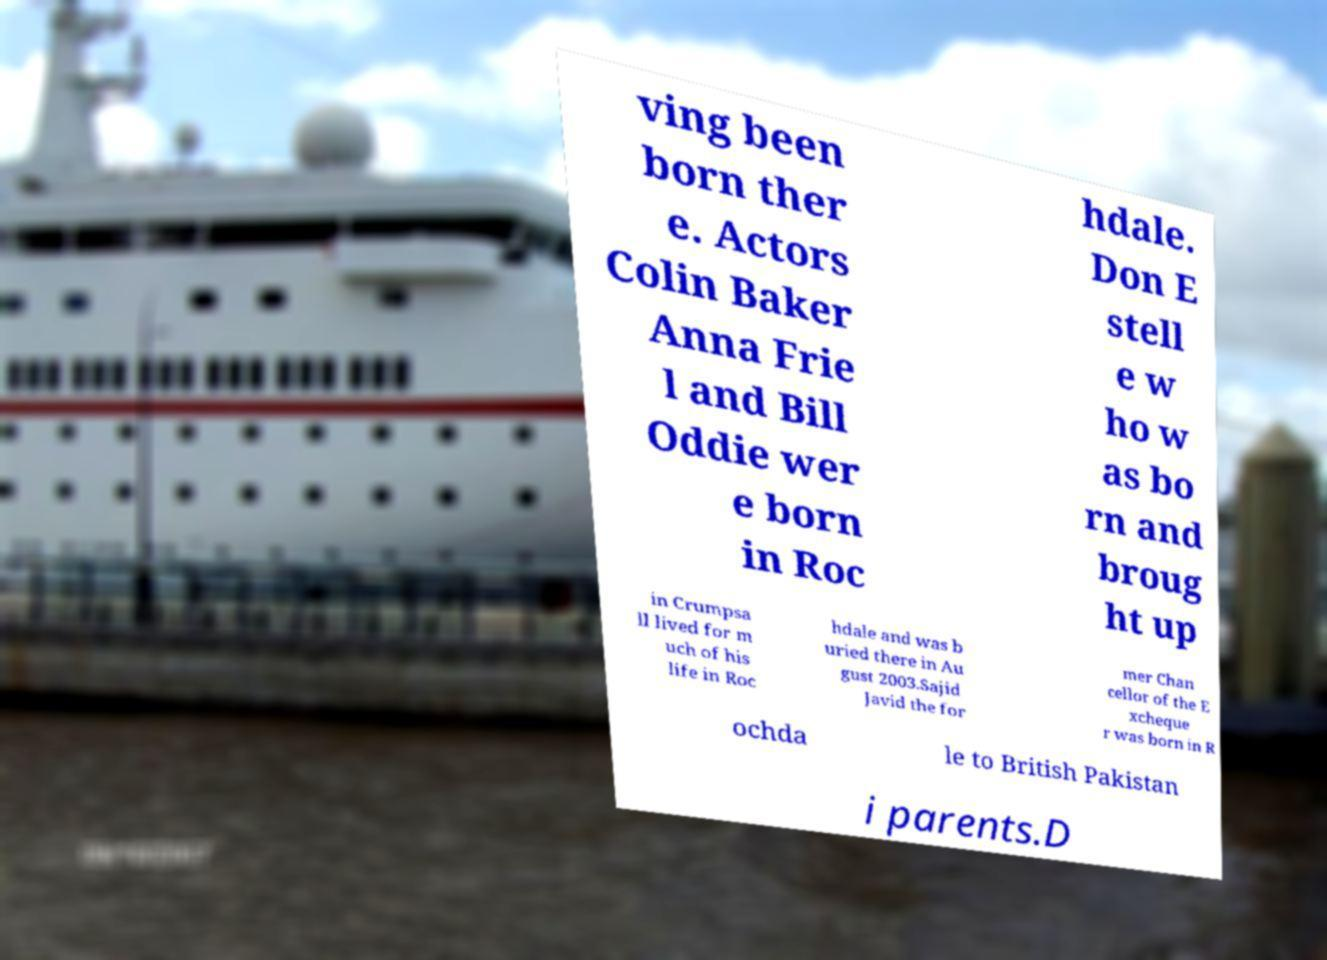Please read and relay the text visible in this image. What does it say? ving been born ther e. Actors Colin Baker Anna Frie l and Bill Oddie wer e born in Roc hdale. Don E stell e w ho w as bo rn and broug ht up in Crumpsa ll lived for m uch of his life in Roc hdale and was b uried there in Au gust 2003.Sajid Javid the for mer Chan cellor of the E xcheque r was born in R ochda le to British Pakistan i parents.D 